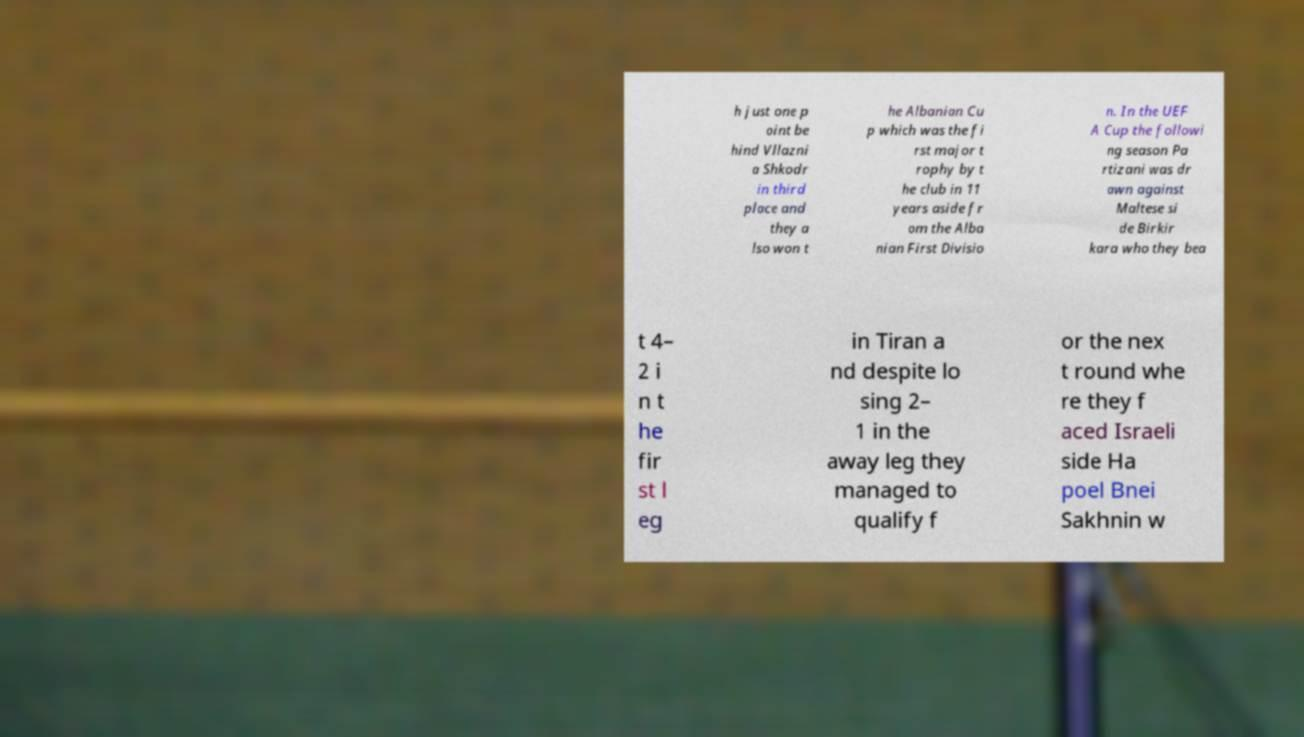Can you accurately transcribe the text from the provided image for me? h just one p oint be hind Vllazni a Shkodr in third place and they a lso won t he Albanian Cu p which was the fi rst major t rophy by t he club in 11 years aside fr om the Alba nian First Divisio n. In the UEF A Cup the followi ng season Pa rtizani was dr awn against Maltese si de Birkir kara who they bea t 4– 2 i n t he fir st l eg in Tiran a nd despite lo sing 2– 1 in the away leg they managed to qualify f or the nex t round whe re they f aced Israeli side Ha poel Bnei Sakhnin w 